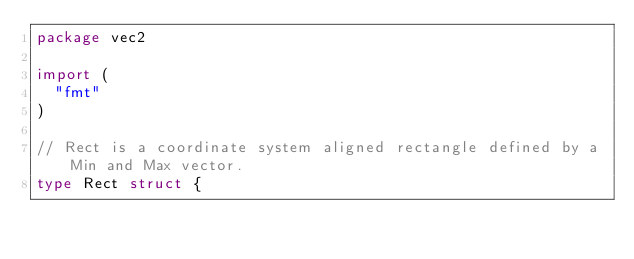<code> <loc_0><loc_0><loc_500><loc_500><_Go_>package vec2

import (
	"fmt"
)

// Rect is a coordinate system aligned rectangle defined by a Min and Max vector.
type Rect struct {</code> 